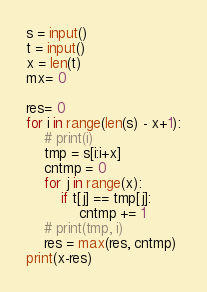Convert code to text. <code><loc_0><loc_0><loc_500><loc_500><_Python_>s = input()
t = input()
x = len(t)
mx= 0

res= 0
for i in range(len(s) - x+1):
    # print(i)
    tmp = s[i:i+x]
    cntmp = 0
    for j in range(x):
        if t[j] == tmp[j]:
            cntmp += 1
    # print(tmp, i)
    res = max(res, cntmp)
print(x-res)</code> 